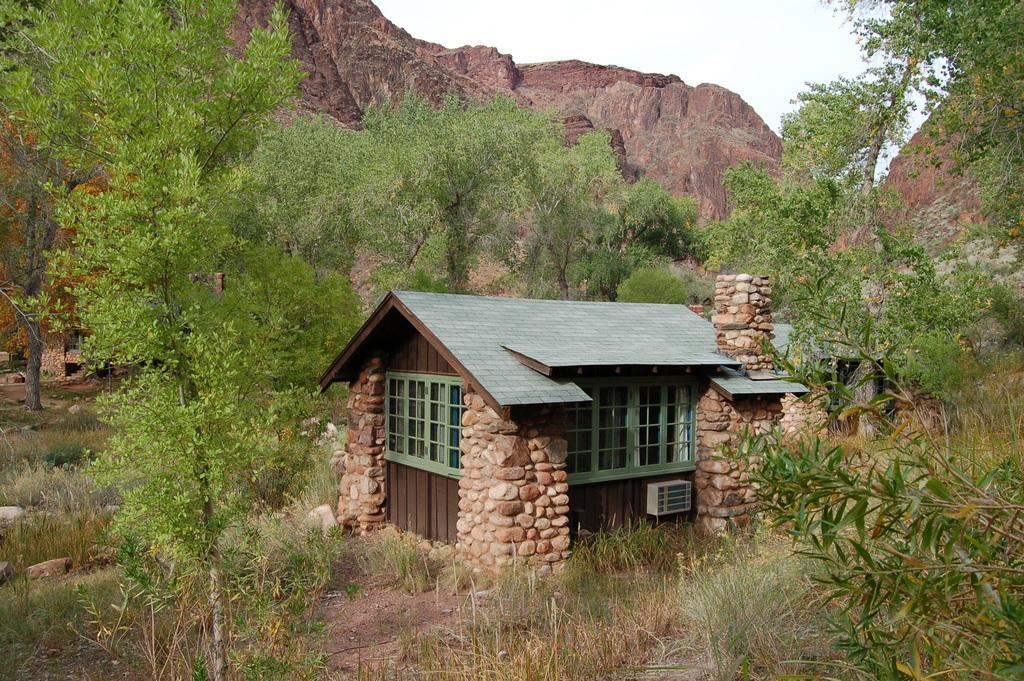How would you summarize this image in a sentence or two? In the middle I can see a house, grass, trees, mountains and the sky. This image is taken may be during a day. 